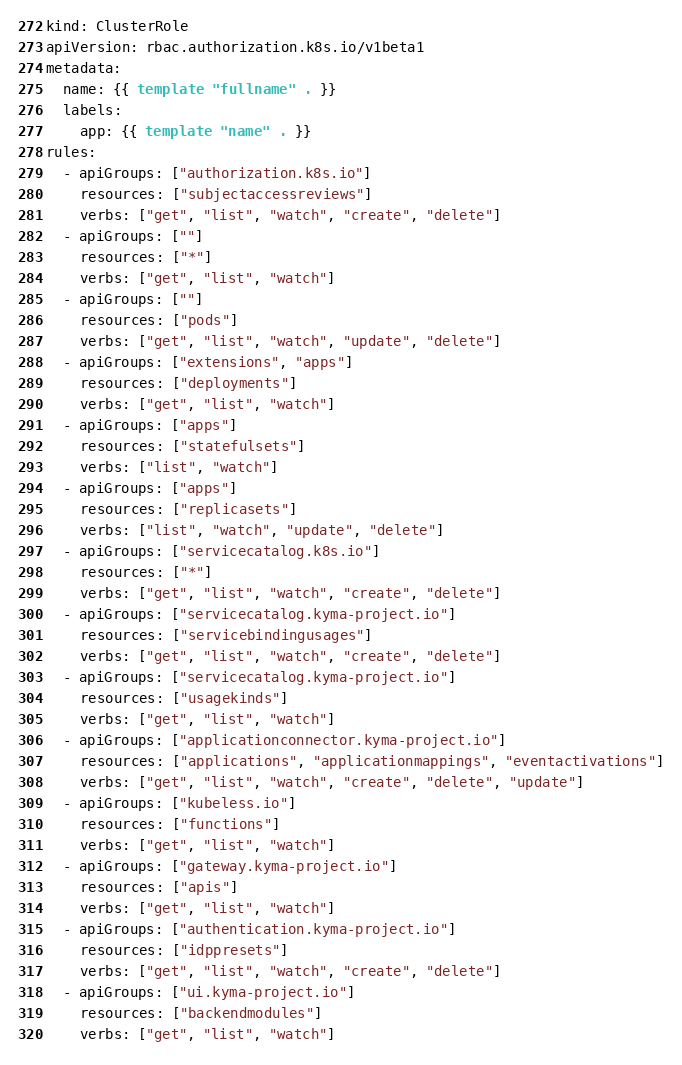Convert code to text. <code><loc_0><loc_0><loc_500><loc_500><_YAML_>kind: ClusterRole
apiVersion: rbac.authorization.k8s.io/v1beta1
metadata:
  name: {{ template "fullname" . }}
  labels:
    app: {{ template "name" . }}
rules:
  - apiGroups: ["authorization.k8s.io"]
    resources: ["subjectaccessreviews"]
    verbs: ["get", "list", "watch", "create", "delete"]
  - apiGroups: [""]
    resources: ["*"]
    verbs: ["get", "list", "watch"]
  - apiGroups: [""]
    resources: ["pods"]
    verbs: ["get", "list", "watch", "update", "delete"]
  - apiGroups: ["extensions", "apps"]
    resources: ["deployments"]
    verbs: ["get", "list", "watch"]
  - apiGroups: ["apps"]
    resources: ["statefulsets"]
    verbs: ["list", "watch"]
  - apiGroups: ["apps"]
    resources: ["replicasets"]
    verbs: ["list", "watch", "update", "delete"]
  - apiGroups: ["servicecatalog.k8s.io"]
    resources: ["*"]
    verbs: ["get", "list", "watch", "create", "delete"]
  - apiGroups: ["servicecatalog.kyma-project.io"]
    resources: ["servicebindingusages"]
    verbs: ["get", "list", "watch", "create", "delete"]
  - apiGroups: ["servicecatalog.kyma-project.io"]
    resources: ["usagekinds"]
    verbs: ["get", "list", "watch"]
  - apiGroups: ["applicationconnector.kyma-project.io"]
    resources: ["applications", "applicationmappings", "eventactivations"]
    verbs: ["get", "list", "watch", "create", "delete", "update"]
  - apiGroups: ["kubeless.io"]
    resources: ["functions"]
    verbs: ["get", "list", "watch"]
  - apiGroups: ["gateway.kyma-project.io"]
    resources: ["apis"]
    verbs: ["get", "list", "watch"]
  - apiGroups: ["authentication.kyma-project.io"]
    resources: ["idppresets"]
    verbs: ["get", "list", "watch", "create", "delete"]
  - apiGroups: ["ui.kyma-project.io"]
    resources: ["backendmodules"]
    verbs: ["get", "list", "watch"]
</code> 